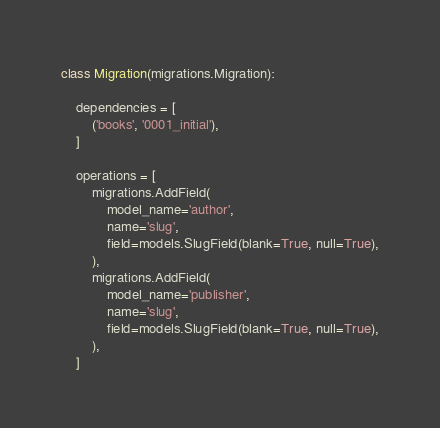Convert code to text. <code><loc_0><loc_0><loc_500><loc_500><_Python_>

class Migration(migrations.Migration):

    dependencies = [
        ('books', '0001_initial'),
    ]

    operations = [
        migrations.AddField(
            model_name='author',
            name='slug',
            field=models.SlugField(blank=True, null=True),
        ),
        migrations.AddField(
            model_name='publisher',
            name='slug',
            field=models.SlugField(blank=True, null=True),
        ),
    ]
</code> 